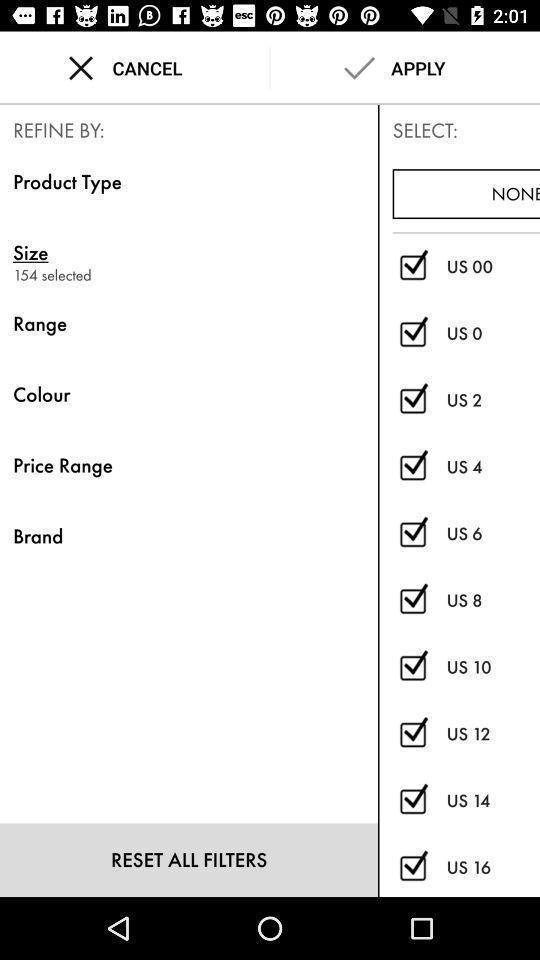Summarize the main components in this picture. Screen showing refine option. 